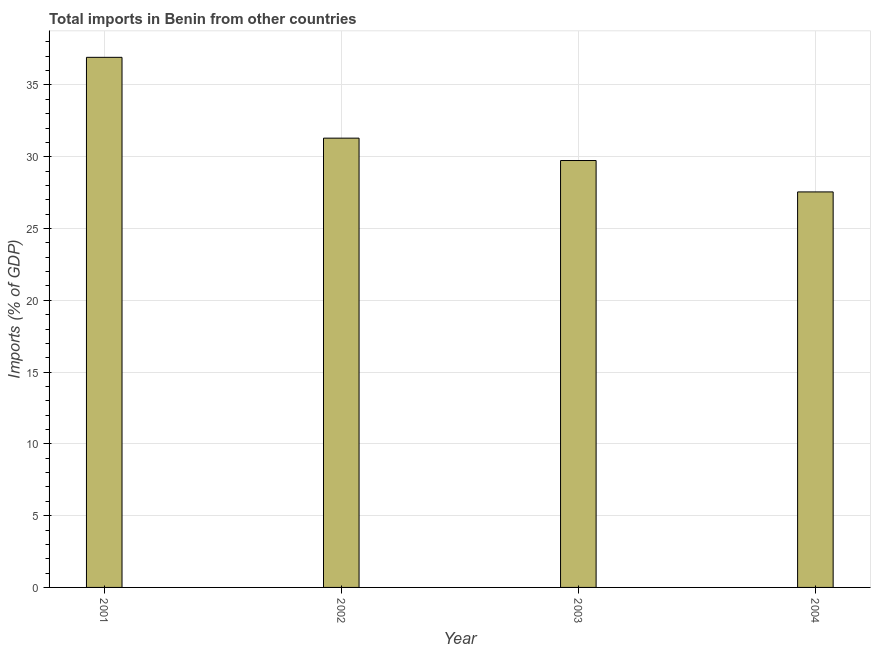Does the graph contain grids?
Offer a very short reply. Yes. What is the title of the graph?
Your answer should be very brief. Total imports in Benin from other countries. What is the label or title of the X-axis?
Give a very brief answer. Year. What is the label or title of the Y-axis?
Make the answer very short. Imports (% of GDP). What is the total imports in 2001?
Provide a succinct answer. 36.93. Across all years, what is the maximum total imports?
Provide a short and direct response. 36.93. Across all years, what is the minimum total imports?
Your answer should be compact. 27.55. In which year was the total imports minimum?
Offer a terse response. 2004. What is the sum of the total imports?
Your answer should be compact. 125.51. What is the difference between the total imports in 2002 and 2003?
Keep it short and to the point. 1.56. What is the average total imports per year?
Offer a terse response. 31.38. What is the median total imports?
Your response must be concise. 30.52. Do a majority of the years between 2002 and 2004 (inclusive) have total imports greater than 11 %?
Your response must be concise. Yes. What is the ratio of the total imports in 2001 to that in 2004?
Your response must be concise. 1.34. Is the difference between the total imports in 2001 and 2003 greater than the difference between any two years?
Ensure brevity in your answer.  No. What is the difference between the highest and the second highest total imports?
Ensure brevity in your answer.  5.63. Is the sum of the total imports in 2001 and 2002 greater than the maximum total imports across all years?
Give a very brief answer. Yes. What is the difference between the highest and the lowest total imports?
Ensure brevity in your answer.  9.38. How many bars are there?
Ensure brevity in your answer.  4. What is the difference between two consecutive major ticks on the Y-axis?
Offer a terse response. 5. What is the Imports (% of GDP) of 2001?
Provide a short and direct response. 36.93. What is the Imports (% of GDP) in 2002?
Your answer should be very brief. 31.3. What is the Imports (% of GDP) in 2003?
Offer a terse response. 29.74. What is the Imports (% of GDP) in 2004?
Your answer should be very brief. 27.55. What is the difference between the Imports (% of GDP) in 2001 and 2002?
Provide a succinct answer. 5.63. What is the difference between the Imports (% of GDP) in 2001 and 2003?
Offer a very short reply. 7.19. What is the difference between the Imports (% of GDP) in 2001 and 2004?
Ensure brevity in your answer.  9.38. What is the difference between the Imports (% of GDP) in 2002 and 2003?
Keep it short and to the point. 1.56. What is the difference between the Imports (% of GDP) in 2002 and 2004?
Your answer should be very brief. 3.74. What is the difference between the Imports (% of GDP) in 2003 and 2004?
Provide a short and direct response. 2.19. What is the ratio of the Imports (% of GDP) in 2001 to that in 2002?
Make the answer very short. 1.18. What is the ratio of the Imports (% of GDP) in 2001 to that in 2003?
Provide a short and direct response. 1.24. What is the ratio of the Imports (% of GDP) in 2001 to that in 2004?
Offer a terse response. 1.34. What is the ratio of the Imports (% of GDP) in 2002 to that in 2003?
Your answer should be compact. 1.05. What is the ratio of the Imports (% of GDP) in 2002 to that in 2004?
Provide a succinct answer. 1.14. What is the ratio of the Imports (% of GDP) in 2003 to that in 2004?
Your response must be concise. 1.08. 